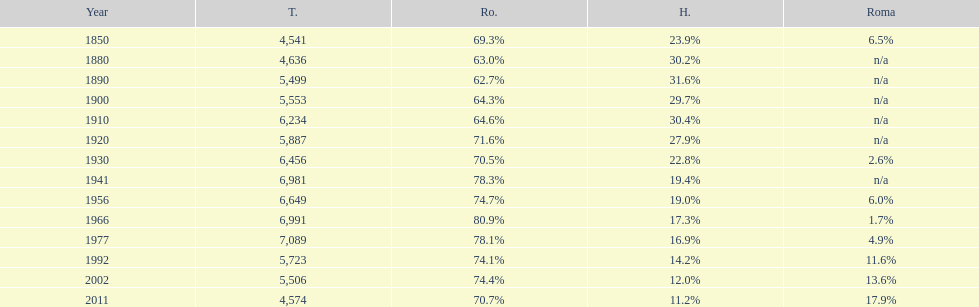Which year witnessed the peak percentage in the romanian population? 1966. 